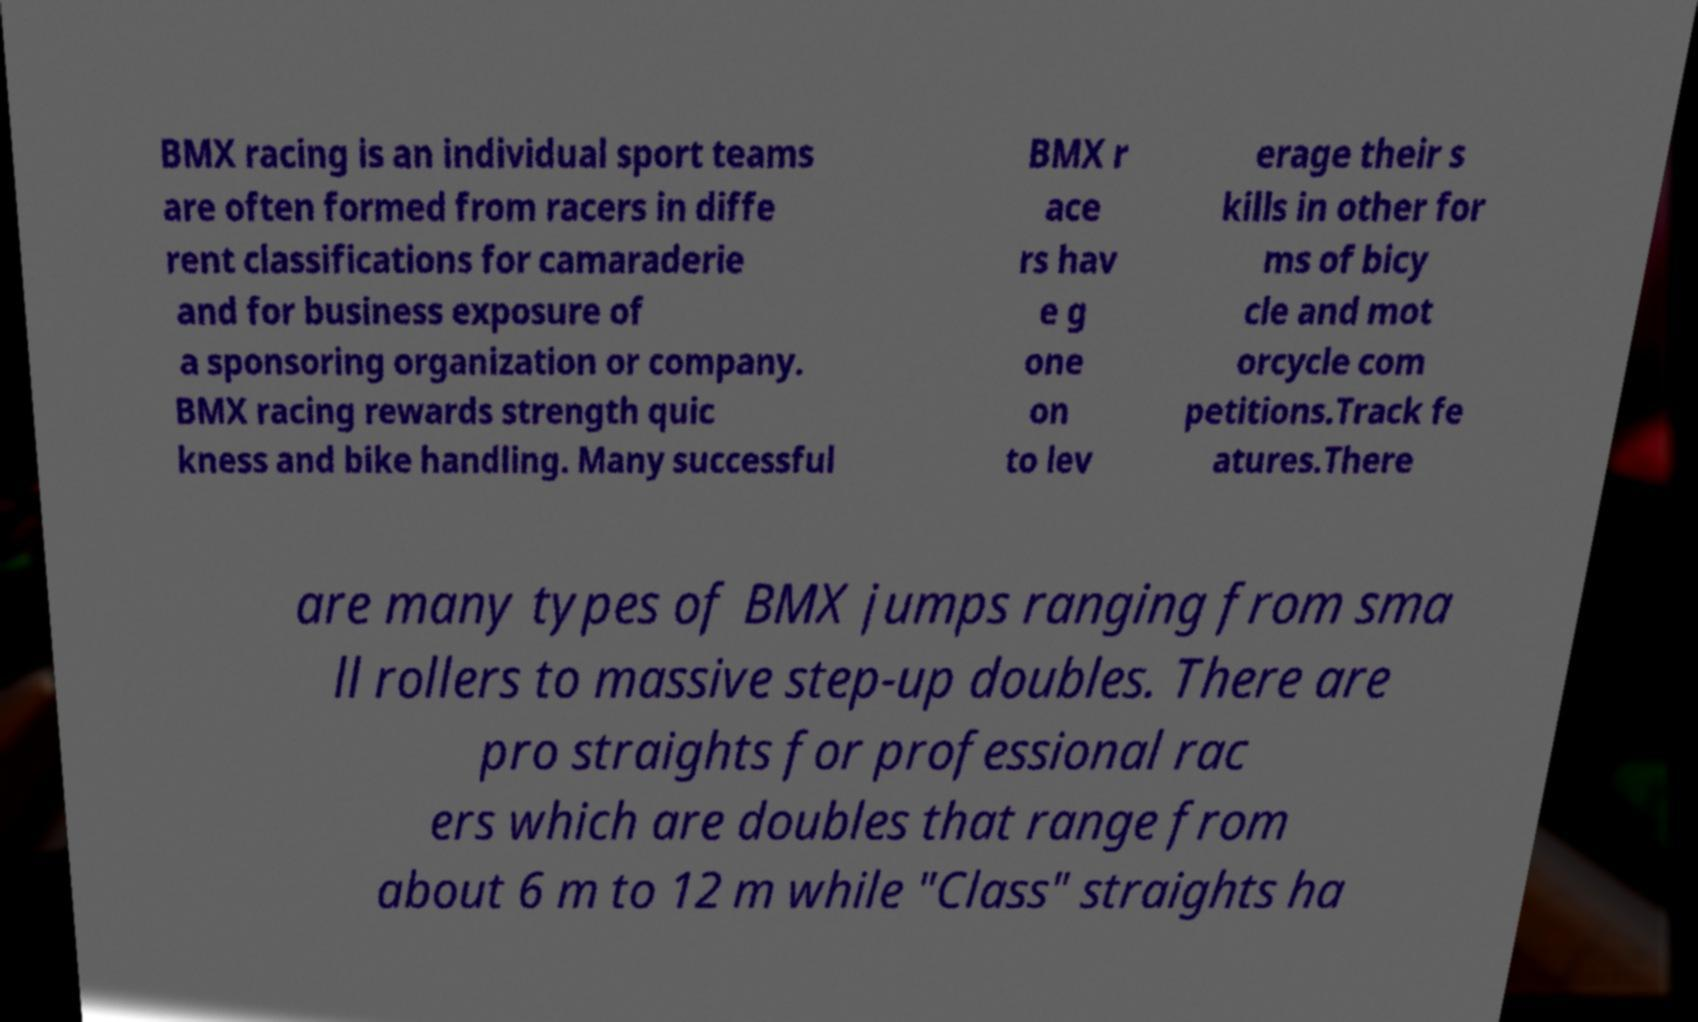Please identify and transcribe the text found in this image. BMX racing is an individual sport teams are often formed from racers in diffe rent classifications for camaraderie and for business exposure of a sponsoring organization or company. BMX racing rewards strength quic kness and bike handling. Many successful BMX r ace rs hav e g one on to lev erage their s kills in other for ms of bicy cle and mot orcycle com petitions.Track fe atures.There are many types of BMX jumps ranging from sma ll rollers to massive step-up doubles. There are pro straights for professional rac ers which are doubles that range from about 6 m to 12 m while "Class" straights ha 